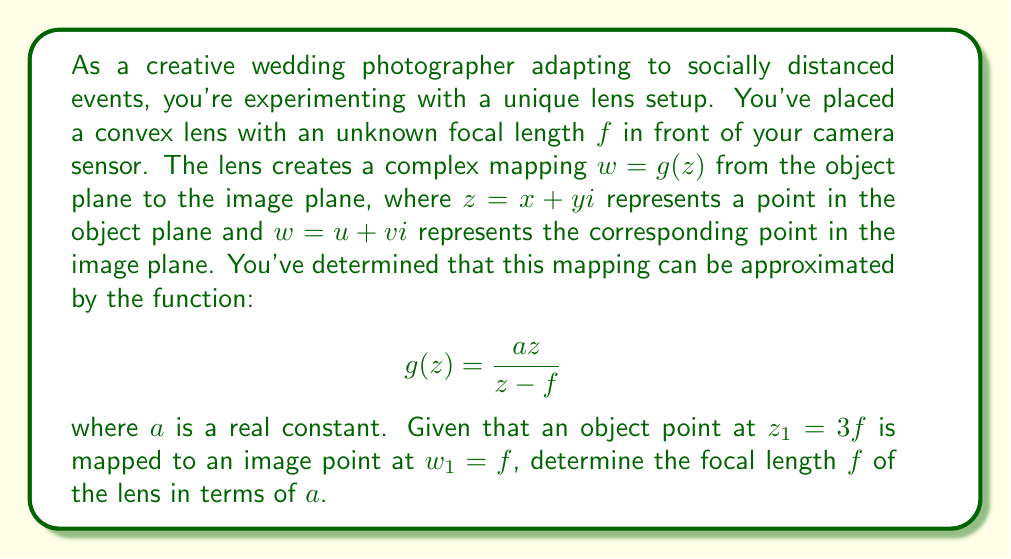Teach me how to tackle this problem. Let's approach this step-by-step:

1) We're given that $g(z) = \frac{az}{z - f}$ and that $g(3f) = f$.

2) Let's substitute these values into the function:

   $$f = g(3f) = \frac{a(3f)}{3f - f} = \frac{3af}{2f}$$

3) Now we can solve this equation for $f$:

   $$f = \frac{3af}{2f}$$
   $$2f^2 = 3af$$
   $$f = \frac{3a}{2}$$

4) To verify, let's substitute this back into the original function:

   $$g(3f) = g(\frac{9a}{2}) = \frac{a(\frac{9a}{2})}{\frac{9a}{2} - \frac{3a}{2}} = \frac{\frac{9a^2}{2}}{\frac{6a}{2}} = \frac{9a^2}{6a} = \frac{3a}{2} = f$$

This confirms our solution.

5) The focal length $f$ is therefore equal to $\frac{3a}{2}$.

This result shows how the complex function transformation relates to the physical properties of the lens, connecting the mathematical model to the real-world optical system you're using in your creative wedding photography.
Answer: $f = \frac{3a}{2}$ 